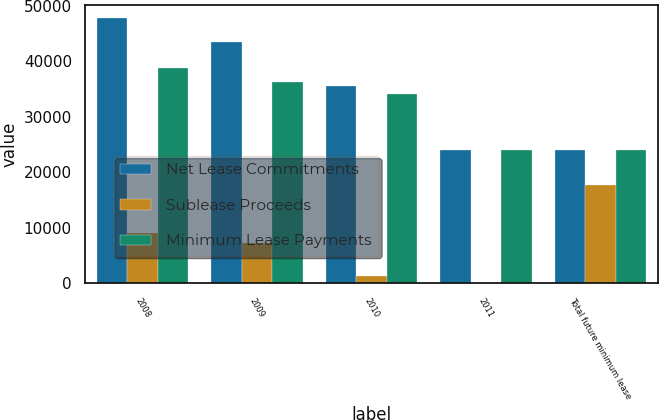Convert chart to OTSL. <chart><loc_0><loc_0><loc_500><loc_500><stacked_bar_chart><ecel><fcel>2008<fcel>2009<fcel>2010<fcel>2011<fcel>Total future minimum lease<nl><fcel>Net Lease Commitments<fcel>47790<fcel>43440<fcel>35507<fcel>24008<fcel>24008<nl><fcel>Sublease Proceeds<fcel>9023<fcel>7287<fcel>1412<fcel>56<fcel>17778<nl><fcel>Minimum Lease Payments<fcel>38767<fcel>36153<fcel>34095<fcel>23952<fcel>24008<nl></chart> 